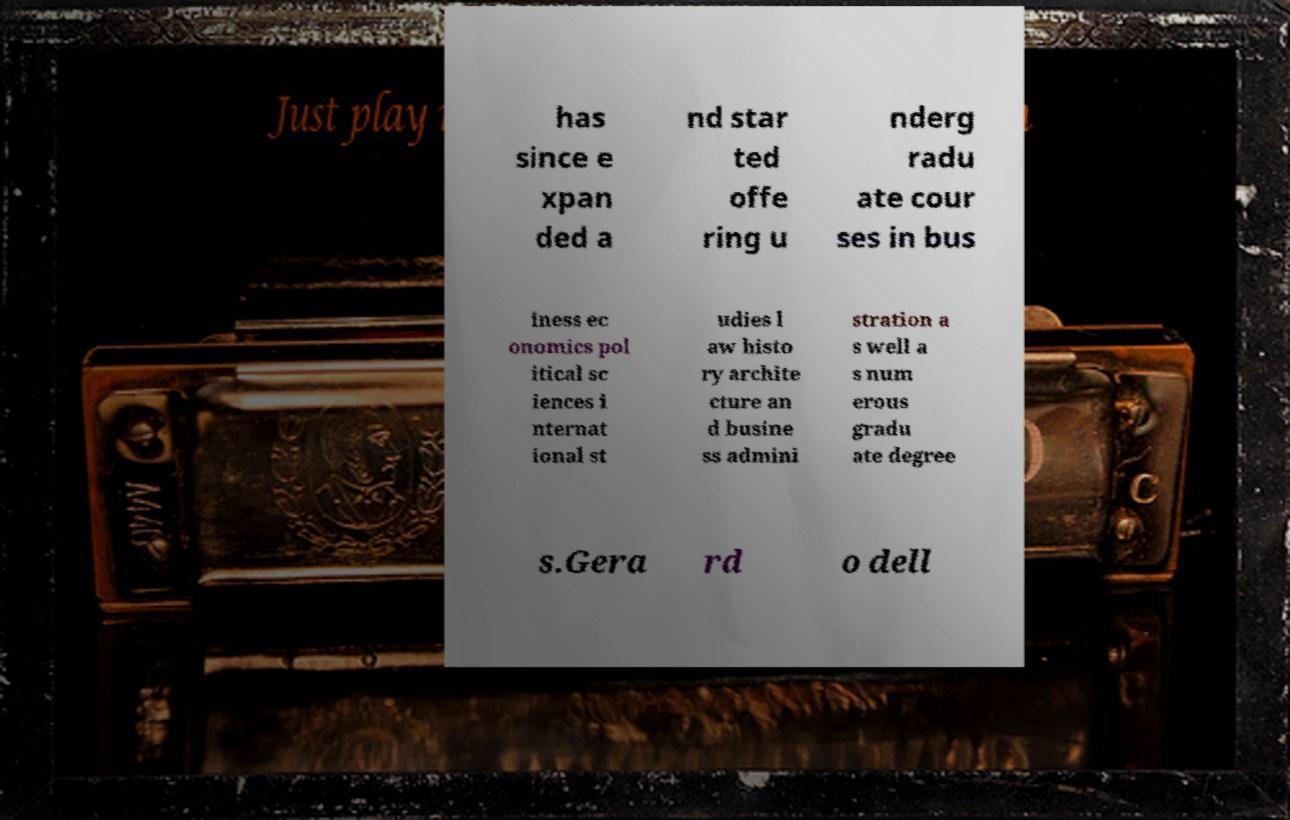What messages or text are displayed in this image? I need them in a readable, typed format. has since e xpan ded a nd star ted offe ring u nderg radu ate cour ses in bus iness ec onomics pol itical sc iences i nternat ional st udies l aw histo ry archite cture an d busine ss admini stration a s well a s num erous gradu ate degree s.Gera rd o dell 